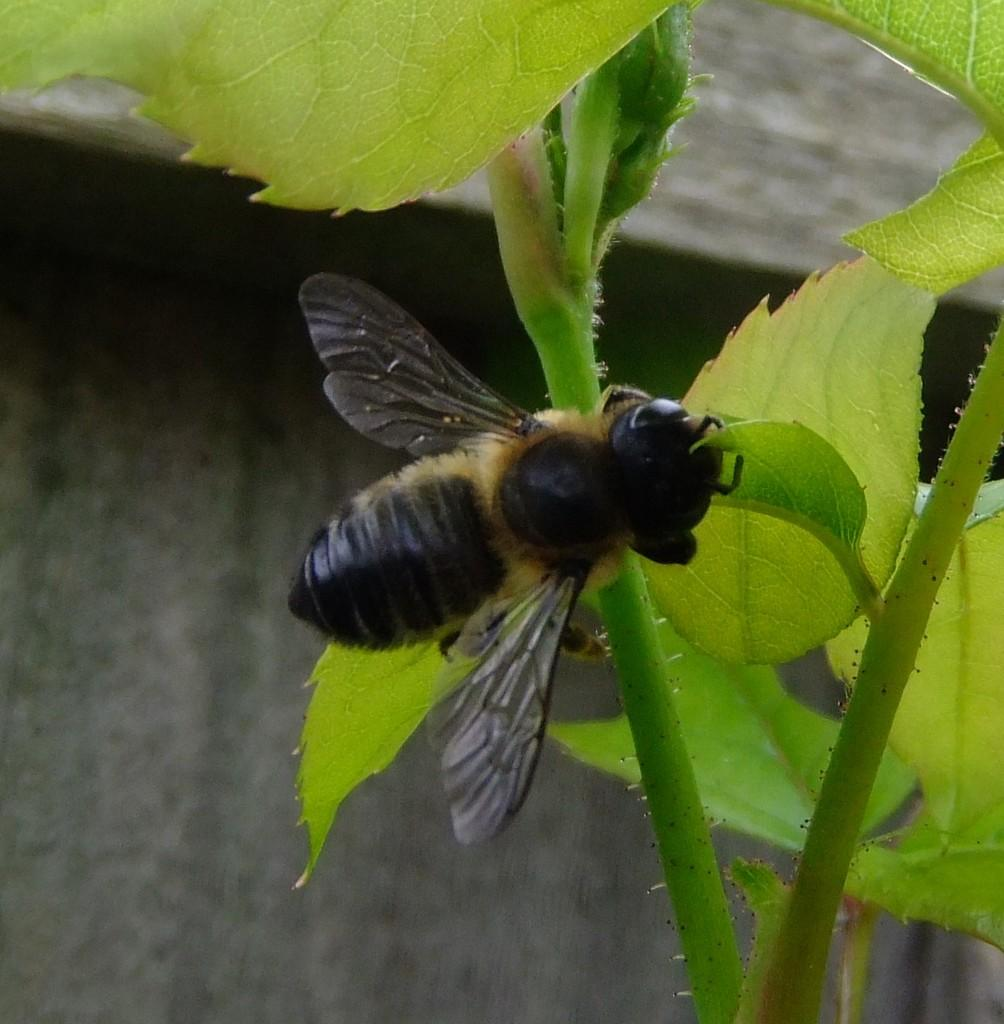What type of insect is present in the image? There is a bee in the image. Where is the bee located on the plant? The bee is on the stem of a plant. What type of seat can be seen in the image? There is no seat present in the image. Is there any wire visible in the image? There is no wire visible in the image. Where is the dock located in the image? There is no dock present in the image. 